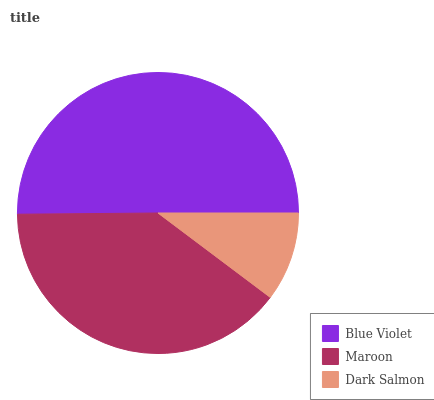Is Dark Salmon the minimum?
Answer yes or no. Yes. Is Blue Violet the maximum?
Answer yes or no. Yes. Is Maroon the minimum?
Answer yes or no. No. Is Maroon the maximum?
Answer yes or no. No. Is Blue Violet greater than Maroon?
Answer yes or no. Yes. Is Maroon less than Blue Violet?
Answer yes or no. Yes. Is Maroon greater than Blue Violet?
Answer yes or no. No. Is Blue Violet less than Maroon?
Answer yes or no. No. Is Maroon the high median?
Answer yes or no. Yes. Is Maroon the low median?
Answer yes or no. Yes. Is Blue Violet the high median?
Answer yes or no. No. Is Dark Salmon the low median?
Answer yes or no. No. 